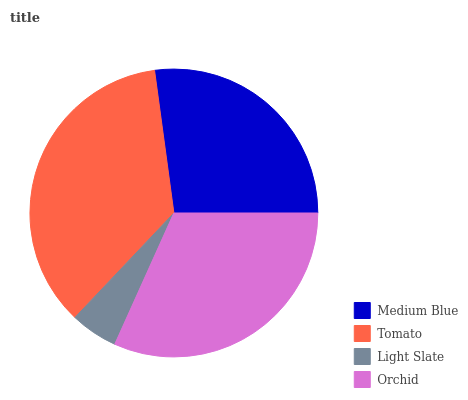Is Light Slate the minimum?
Answer yes or no. Yes. Is Tomato the maximum?
Answer yes or no. Yes. Is Tomato the minimum?
Answer yes or no. No. Is Light Slate the maximum?
Answer yes or no. No. Is Tomato greater than Light Slate?
Answer yes or no. Yes. Is Light Slate less than Tomato?
Answer yes or no. Yes. Is Light Slate greater than Tomato?
Answer yes or no. No. Is Tomato less than Light Slate?
Answer yes or no. No. Is Orchid the high median?
Answer yes or no. Yes. Is Medium Blue the low median?
Answer yes or no. Yes. Is Medium Blue the high median?
Answer yes or no. No. Is Tomato the low median?
Answer yes or no. No. 